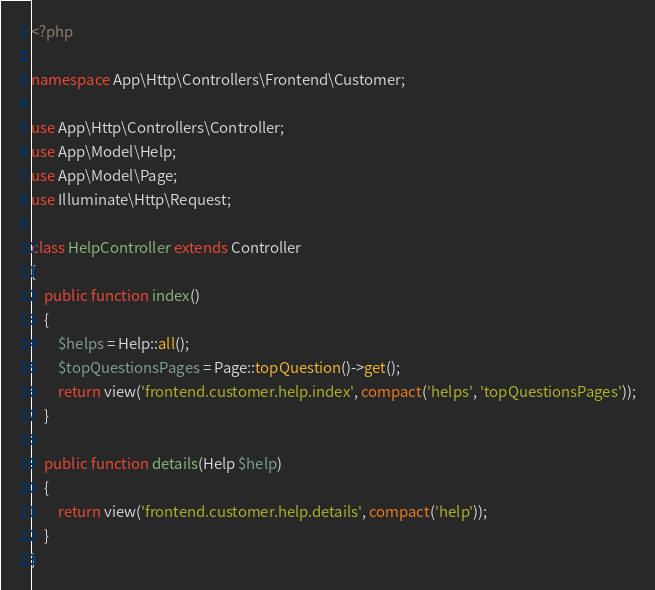<code> <loc_0><loc_0><loc_500><loc_500><_PHP_><?php

namespace App\Http\Controllers\Frontend\Customer;

use App\Http\Controllers\Controller;
use App\Model\Help;
use App\Model\Page;
use Illuminate\Http\Request;

class HelpController extends Controller
{
    public function index()
    {
        $helps = Help::all();
        $topQuestionsPages = Page::topQuestion()->get();
        return view('frontend.customer.help.index', compact('helps', 'topQuestionsPages'));
    }

    public function details(Help $help)
    {
        return view('frontend.customer.help.details', compact('help'));
    }
}
</code> 